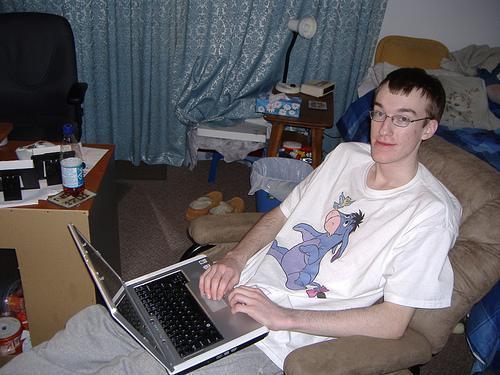How many people are in the photo?
Give a very brief answer. 1. 